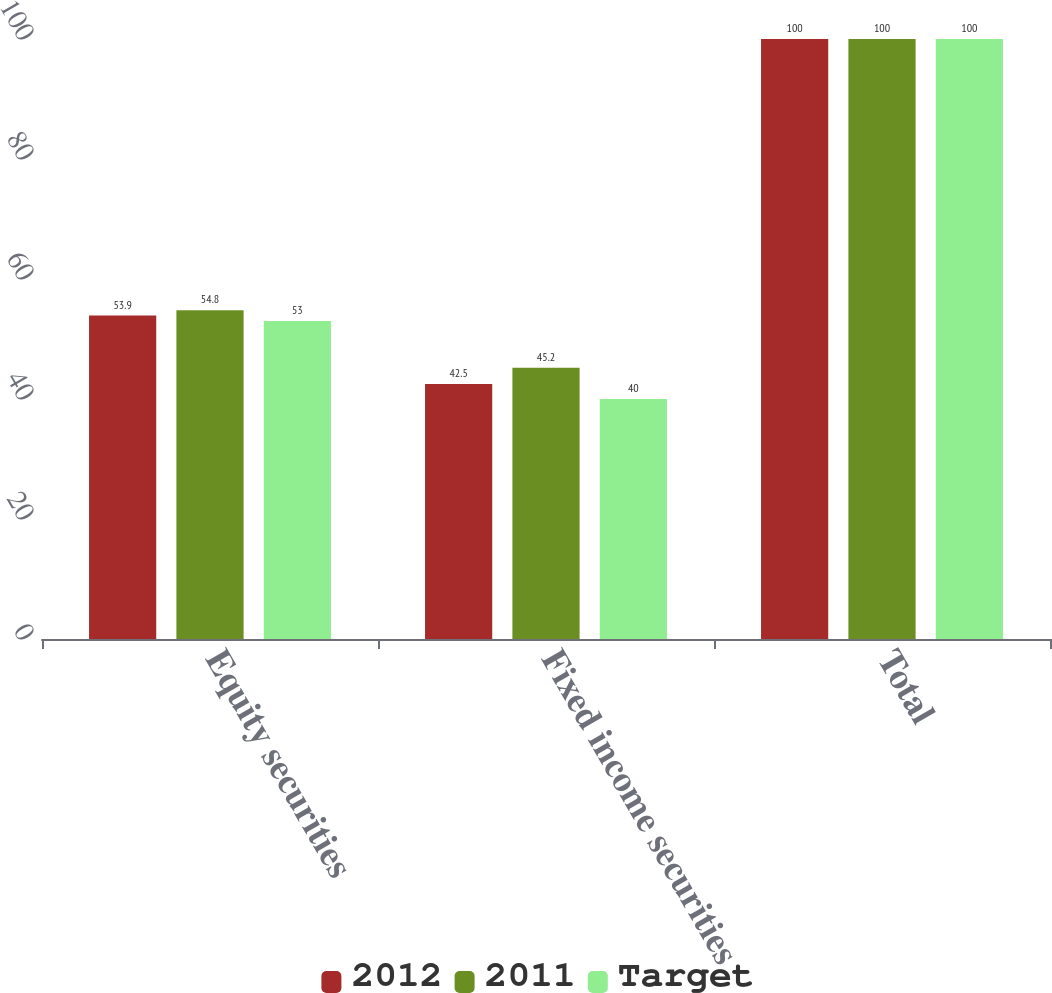Convert chart. <chart><loc_0><loc_0><loc_500><loc_500><stacked_bar_chart><ecel><fcel>Equity securities<fcel>Fixed income securities<fcel>Total<nl><fcel>2012<fcel>53.9<fcel>42.5<fcel>100<nl><fcel>2011<fcel>54.8<fcel>45.2<fcel>100<nl><fcel>Target<fcel>53<fcel>40<fcel>100<nl></chart> 